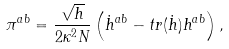Convert formula to latex. <formula><loc_0><loc_0><loc_500><loc_500>\pi ^ { a b } = \frac { \sqrt { h } } { 2 \kappa ^ { 2 } N } \left ( \dot { h } ^ { a b } - t r ( \dot { h } ) h ^ { a b } \right ) ,</formula> 